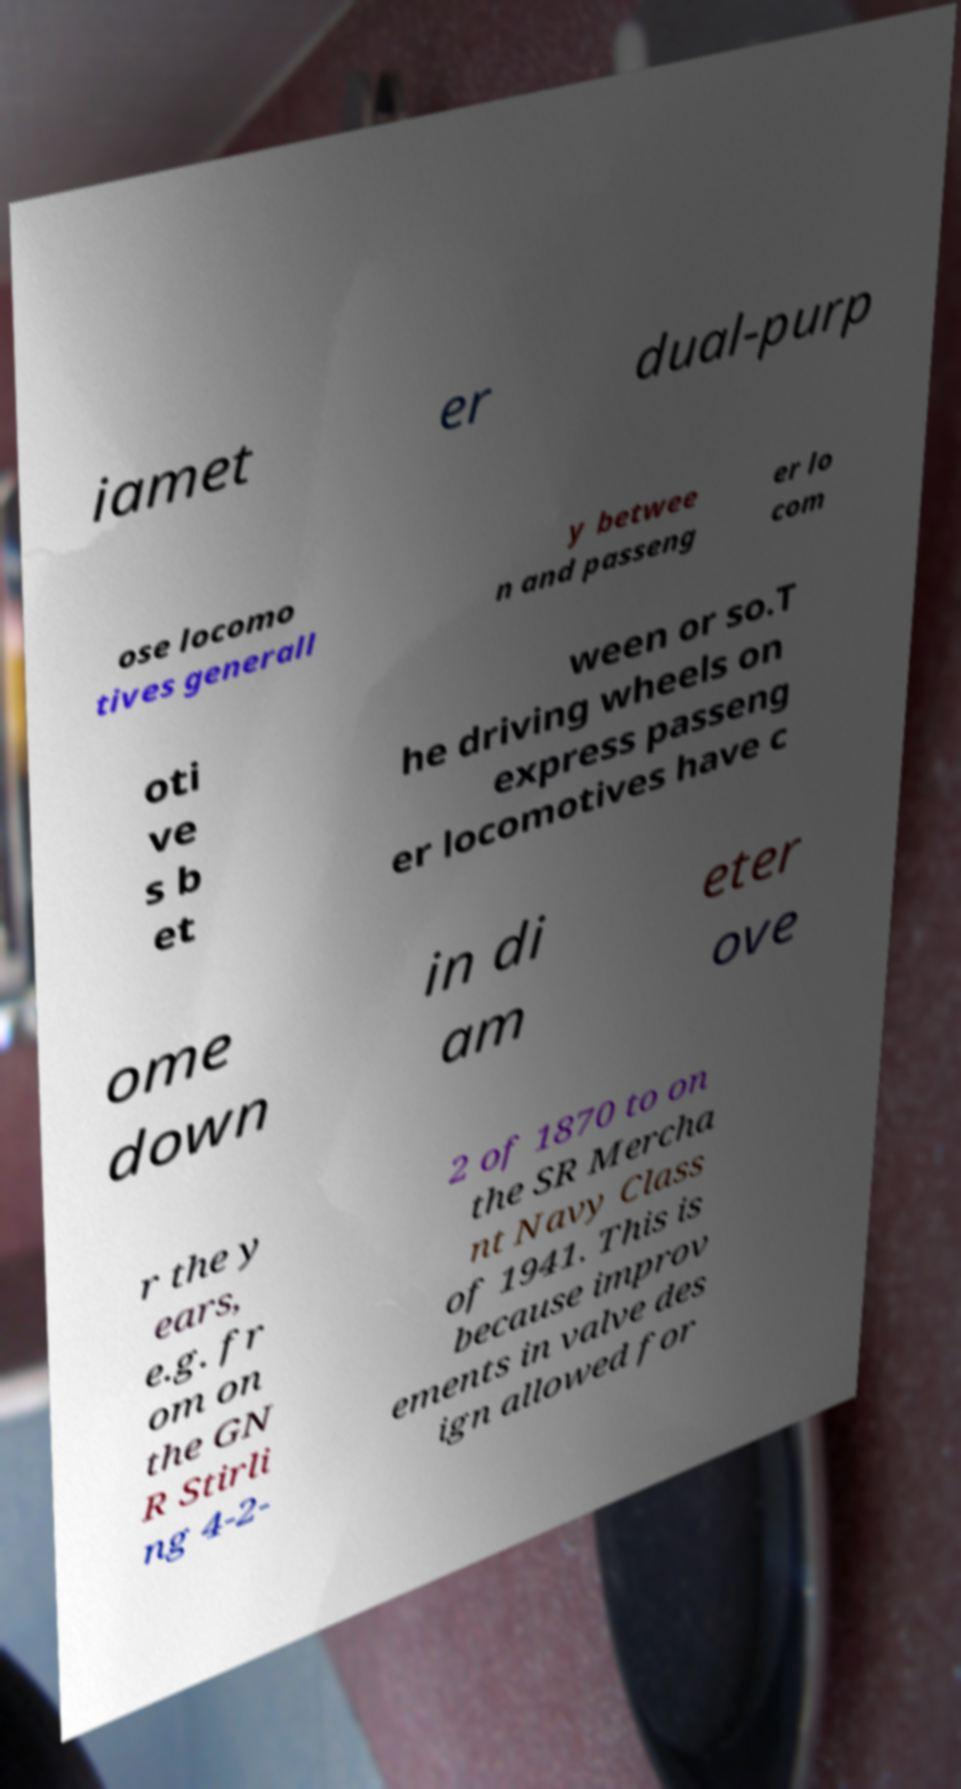Could you extract and type out the text from this image? iamet er dual-purp ose locomo tives generall y betwee n and passeng er lo com oti ve s b et ween or so.T he driving wheels on express passeng er locomotives have c ome down in di am eter ove r the y ears, e.g. fr om on the GN R Stirli ng 4-2- 2 of 1870 to on the SR Mercha nt Navy Class of 1941. This is because improv ements in valve des ign allowed for 